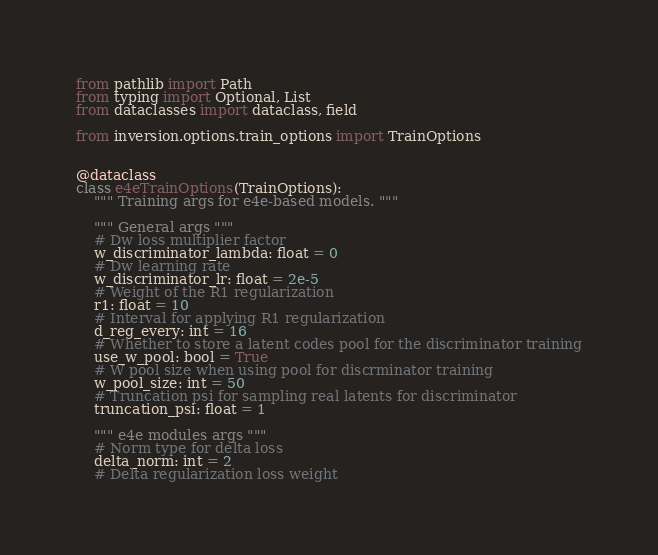Convert code to text. <code><loc_0><loc_0><loc_500><loc_500><_Python_>from pathlib import Path
from typing import Optional, List
from dataclasses import dataclass, field

from inversion.options.train_options import TrainOptions


@dataclass
class e4eTrainOptions(TrainOptions):
    """ Training args for e4e-based models. """

    """ General args """
    # Dw loss multiplier factor
    w_discriminator_lambda: float = 0
    # Dw learning rate
    w_discriminator_lr: float = 2e-5
    # Weight of the R1 regularization
    r1: float = 10
    # Interval for applying R1 regularization
    d_reg_every: int = 16
    # Whether to store a latent codes pool for the discriminator training
    use_w_pool: bool = True
    # W pool size when using pool for discrminator training
    w_pool_size: int = 50
    # Truncation psi for sampling real latents for discriminator
    truncation_psi: float = 1

    """ e4e modules args """
    # Norm type for delta loss
    delta_norm: int = 2
    # Delta regularization loss weight</code> 